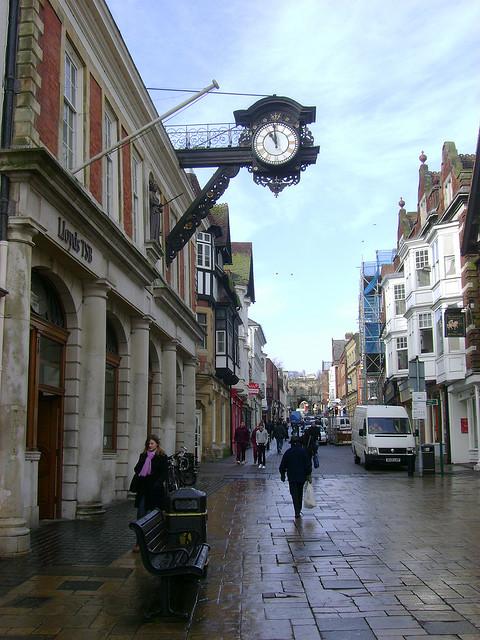What time is shown on the clock?
Write a very short answer. 11:00. Could a bird hit the clock when flying?
Give a very brief answer. Yes. How many stories are the white buildings on the right?
Be succinct. 3. 